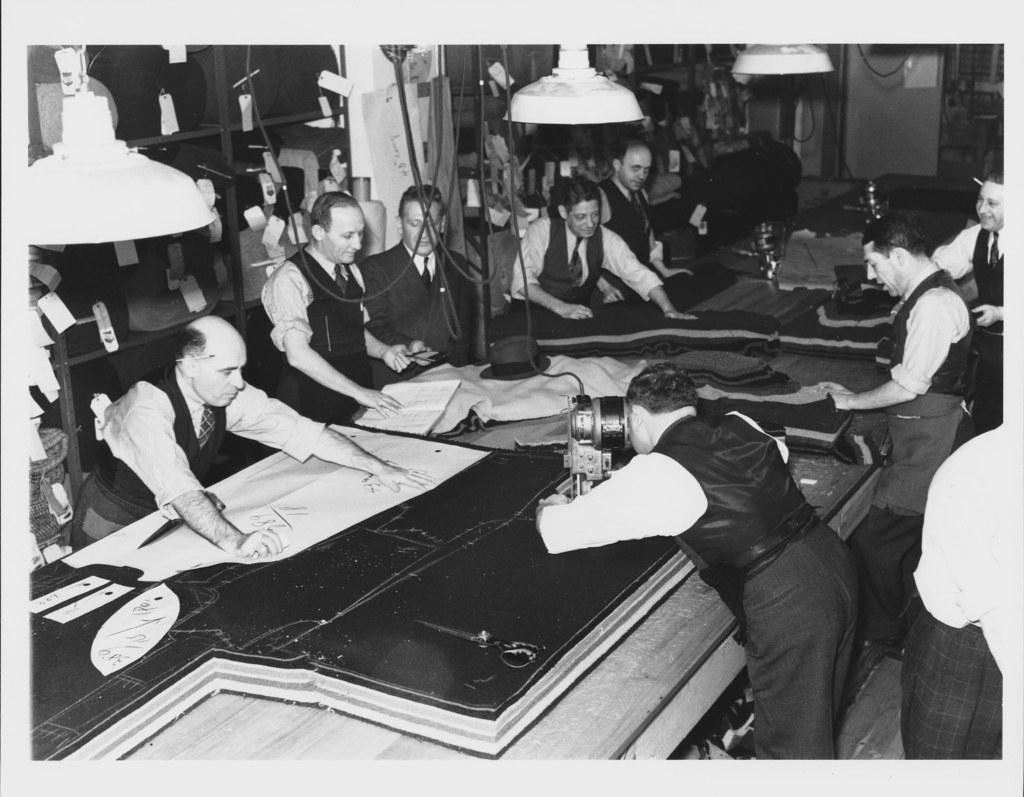Describe this image in one or two sentences. This is a black and white image. In this image we can see a group of men standing beside a table containing some clothes, hat and some devices on it. In that a man is holding a device. We can also see some papers, racks, wires and some ceiling lamps. 